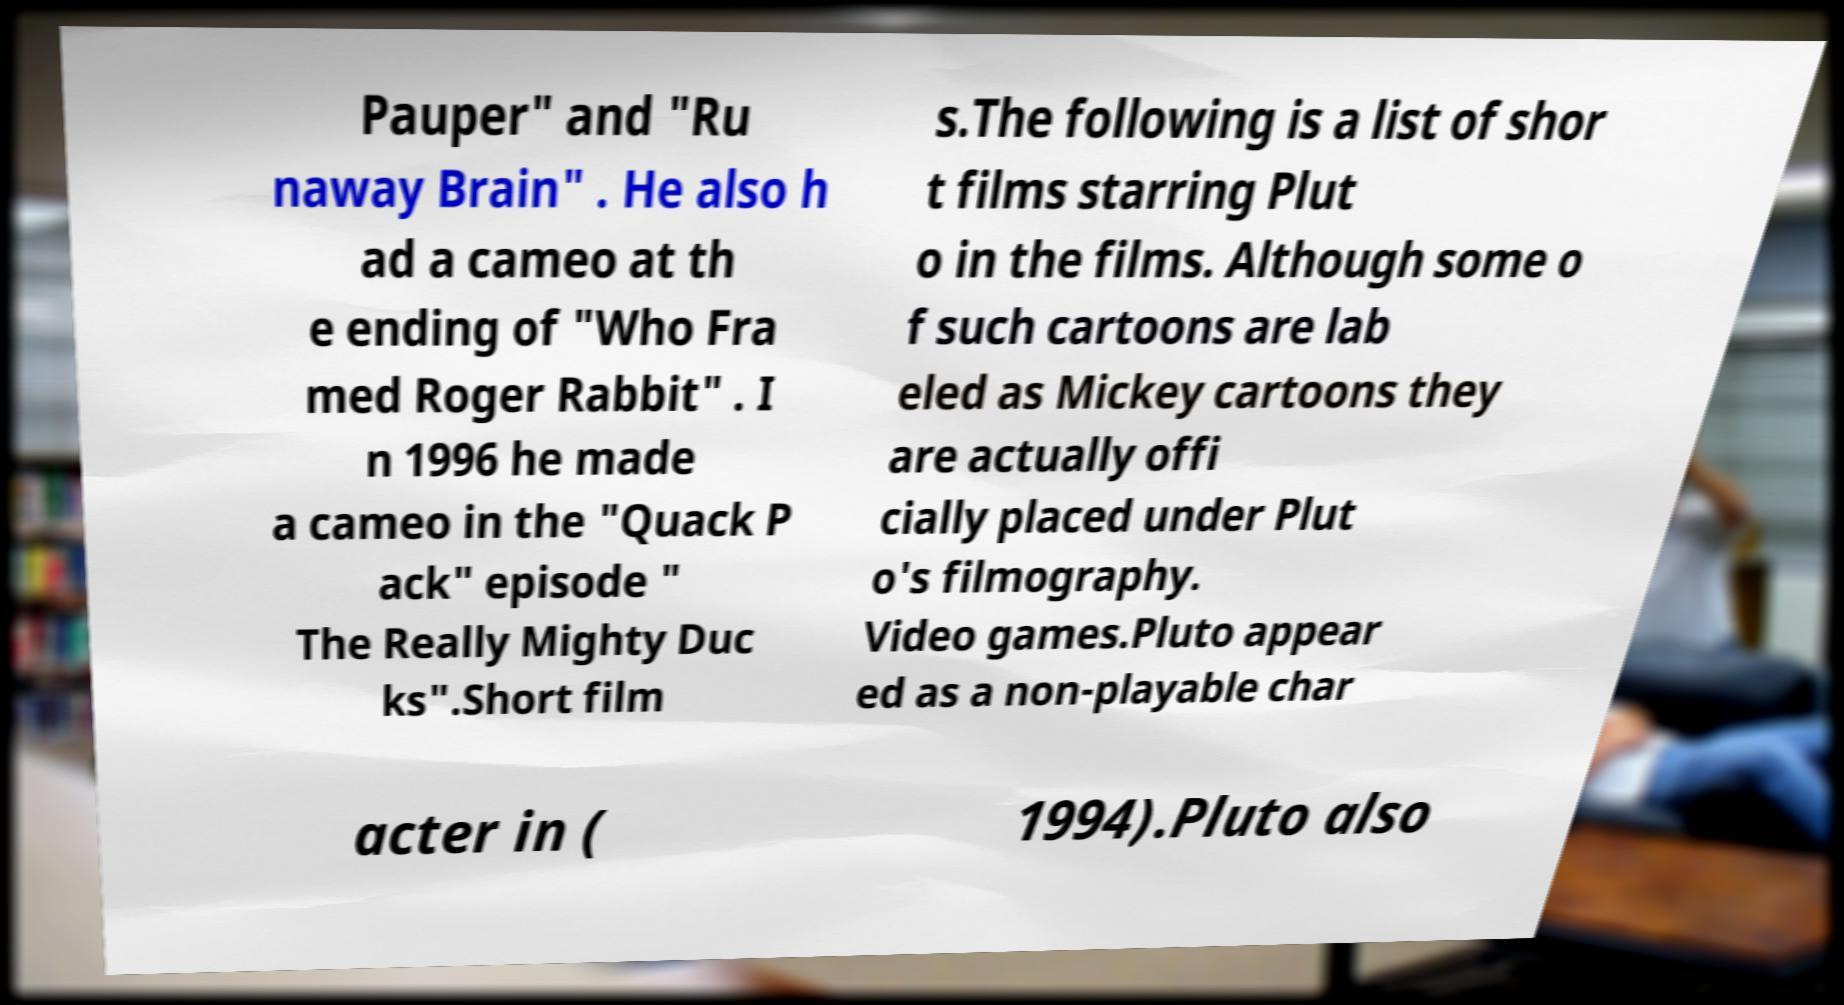For documentation purposes, I need the text within this image transcribed. Could you provide that? Pauper" and "Ru naway Brain" . He also h ad a cameo at th e ending of "Who Fra med Roger Rabbit" . I n 1996 he made a cameo in the "Quack P ack" episode " The Really Mighty Duc ks".Short film s.The following is a list of shor t films starring Plut o in the films. Although some o f such cartoons are lab eled as Mickey cartoons they are actually offi cially placed under Plut o's filmography. Video games.Pluto appear ed as a non-playable char acter in ( 1994).Pluto also 